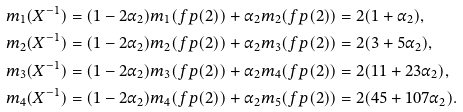Convert formula to latex. <formula><loc_0><loc_0><loc_500><loc_500>m _ { 1 } ( X ^ { - 1 } ) & = ( 1 - 2 \alpha _ { 2 } ) m _ { 1 } ( { f p } ( 2 ) ) + \alpha _ { 2 } m _ { 2 } ( { f p } ( 2 ) ) = 2 ( 1 + \alpha _ { 2 } ) , \\ m _ { 2 } ( X ^ { - 1 } ) & = ( 1 - 2 \alpha _ { 2 } ) m _ { 2 } ( { f p } ( 2 ) ) + \alpha _ { 2 } m _ { 3 } ( { f p } ( 2 ) ) = 2 ( 3 + 5 \alpha _ { 2 } ) , \\ m _ { 3 } ( X ^ { - 1 } ) & = ( 1 - 2 \alpha _ { 2 } ) m _ { 3 } ( { f p } ( 2 ) ) + \alpha _ { 2 } m _ { 4 } ( { f p } ( 2 ) ) = 2 ( 1 1 + 2 3 \alpha _ { 2 } ) , \\ m _ { 4 } ( X ^ { - 1 } ) & = ( 1 - 2 \alpha _ { 2 } ) m _ { 4 } ( { f p } ( 2 ) ) + \alpha _ { 2 } m _ { 5 } ( { f p } ( 2 ) ) = 2 ( 4 5 + 1 0 7 \alpha _ { 2 } ) . \\</formula> 